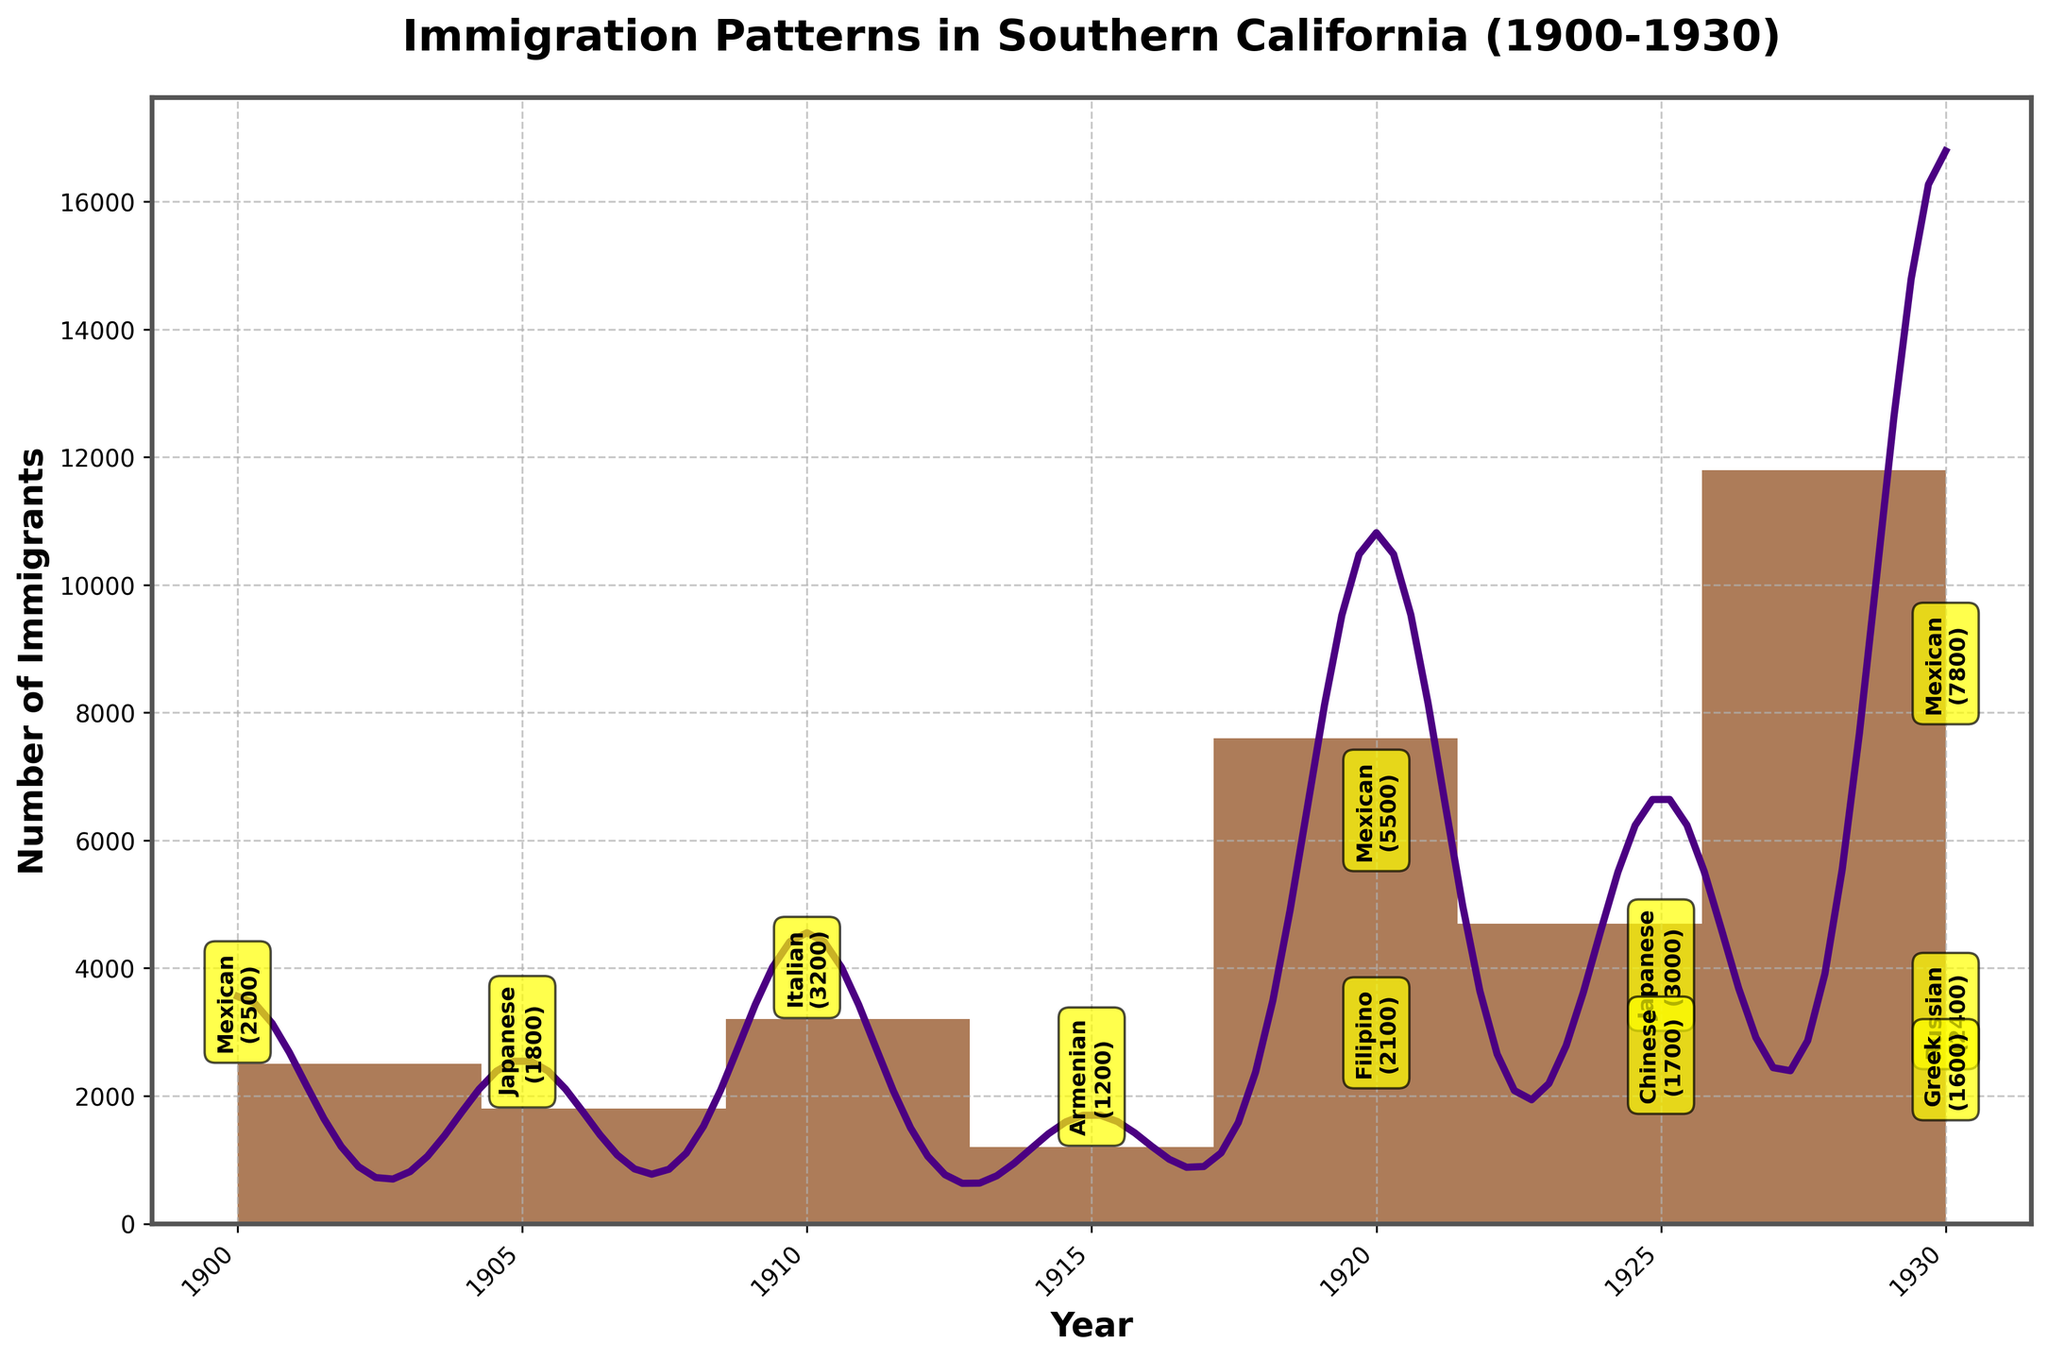How many peaks are visible in the distribution of immigrants in Southern California from 1900-1930? The figure shows two distinct peaks in the histogram with KDE curve, one around 1920 and another around 1930, indicating increased immigration during these years.
Answer: 2 What is the main ethnic group that contributed to the peak in immigration around 1930? The annotation around 1930 shows that the majority of the immigrants were Mexican, with 7800 Mexican immigrants noted.
Answer: Mexican Which year had the highest number of immigrants? The histogram and the KDE curve both show the highest peak around 1930, with annotations indicating 7800 Mexican immigrants among others.
Answer: 1930 What ethnic groups contributed to immigration in 1925? The plot's annotation around the year 1925 indicates immigration from Japanese and Chinese ethnic groups, with 3000 Japanese and 1700 Chinese immigrants.
Answer: Japanese, Chinese Compare the number of Mexican immigrants in 1920 and 1930. Which year had more? In 1920, there were 5500 Mexican immigrants, while in 1930, there were 7800 Mexican immigrants. Therefore, 1930 had more Mexican immigrants.
Answer: 1930 Which ethnic group had the second largest number of immigrants in 1930? The annotations around the year 1930 show that after the Mexican immigrants, the next largest group was Russian with 2400 immigrants.
Answer: Russian What is the span of years covered in this immigration pattern plot? The histogram with KDE curve shows data points starting from the year 1900 to the year 1930, covering a span of 30 years.
Answer: 30 years What does the peak in the KDE curve represent? The peaks on the KDE curve represent periods of higher density or greater numbers of immigrants over specific time frames, corresponding to the peaks in the histogram.
Answer: Periods of higher immigration Identify the ethnic groups contributing to the immigration peak in 1920. The annotations around the year 1920 show immigration from Mexican (5500) and Filipino (2100) groups.
Answer: Mexican, Filipino Is there any year where only one ethnic group contributed to the immigration data? In 1900, the only annotated ethnic group is Mexican with 2500 immigrants, making it the only year with a single contributing group.
Answer: 1900 